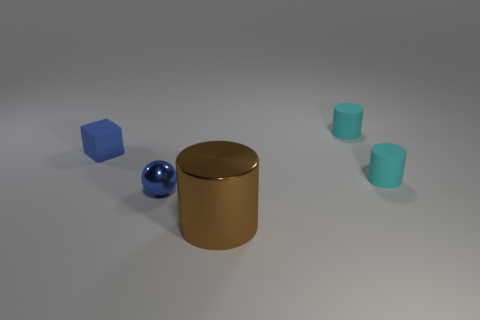Is there anything else that has the same size as the brown metallic cylinder?
Keep it short and to the point. No. There is a blue rubber cube; does it have the same size as the matte cylinder in front of the matte block?
Offer a very short reply. Yes. Are there any things that have the same color as the small ball?
Your answer should be compact. Yes. What size is the blue sphere that is made of the same material as the brown cylinder?
Your answer should be very brief. Small. Is the tiny blue sphere made of the same material as the big brown cylinder?
Your response must be concise. Yes. There is a rubber object behind the rubber thing that is left of the brown shiny cylinder in front of the cube; what is its color?
Offer a terse response. Cyan. What is the shape of the small blue matte object?
Your answer should be very brief. Cube. There is a big metallic thing; is its color the same as the small thing left of the blue metal sphere?
Provide a short and direct response. No. Are there the same number of cyan rubber things to the right of the small blue matte thing and matte cylinders?
Make the answer very short. Yes. How many shiny cylinders have the same size as the brown metallic thing?
Ensure brevity in your answer.  0. 